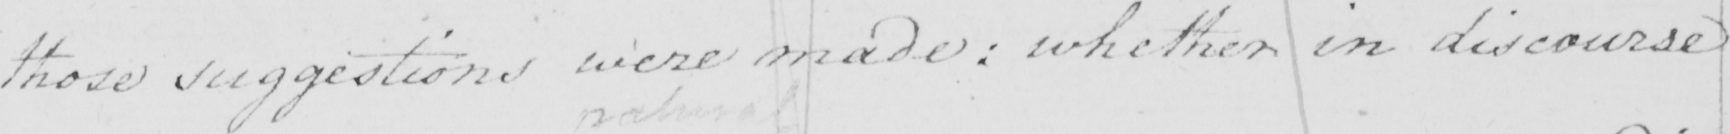What does this handwritten line say? those suggestions were made :  whether in discourse 